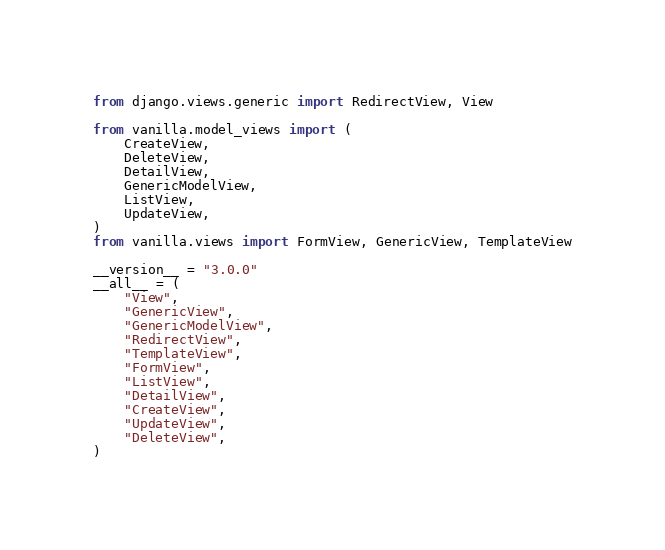Convert code to text. <code><loc_0><loc_0><loc_500><loc_500><_Python_>from django.views.generic import RedirectView, View

from vanilla.model_views import (
    CreateView,
    DeleteView,
    DetailView,
    GenericModelView,
    ListView,
    UpdateView,
)
from vanilla.views import FormView, GenericView, TemplateView

__version__ = "3.0.0"
__all__ = (
    "View",
    "GenericView",
    "GenericModelView",
    "RedirectView",
    "TemplateView",
    "FormView",
    "ListView",
    "DetailView",
    "CreateView",
    "UpdateView",
    "DeleteView",
)
</code> 